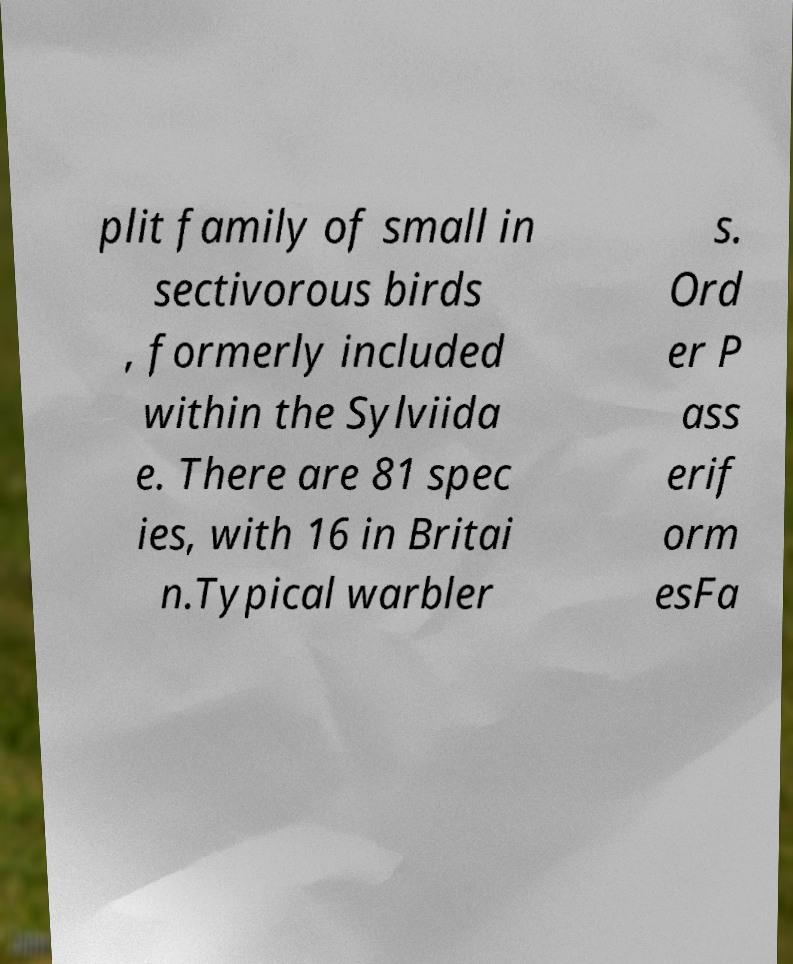Please read and relay the text visible in this image. What does it say? plit family of small in sectivorous birds , formerly included within the Sylviida e. There are 81 spec ies, with 16 in Britai n.Typical warbler s. Ord er P ass erif orm esFa 